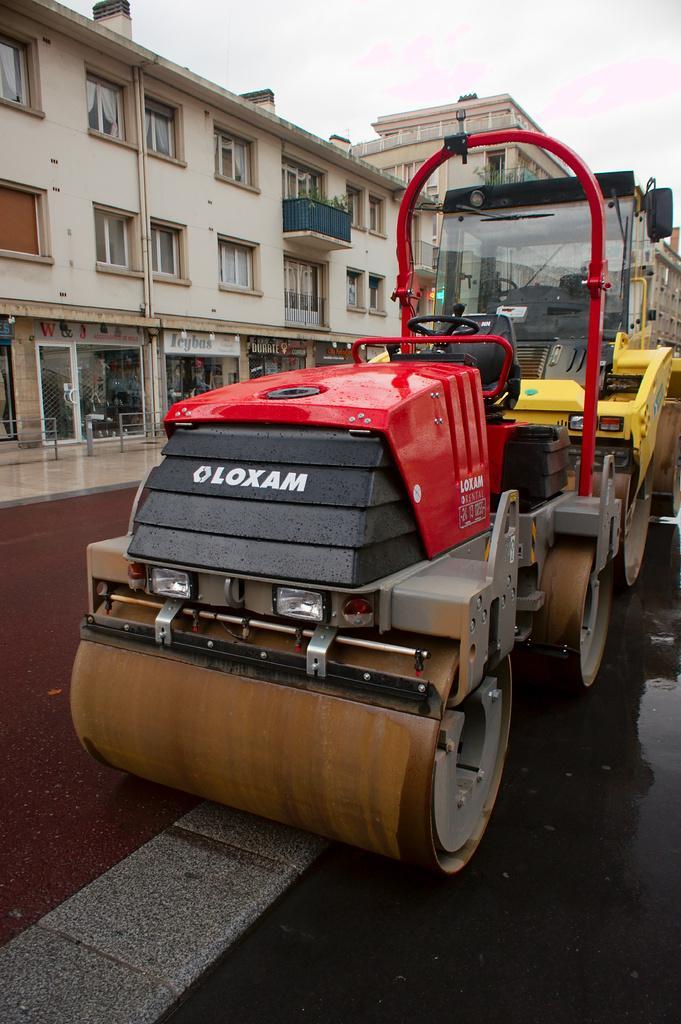Please provide a concise description of this image. In the center of the image there is a road roller. In the background of the image there are buildings. At the bottom of the image there is road. At the top of the image there is sky. 